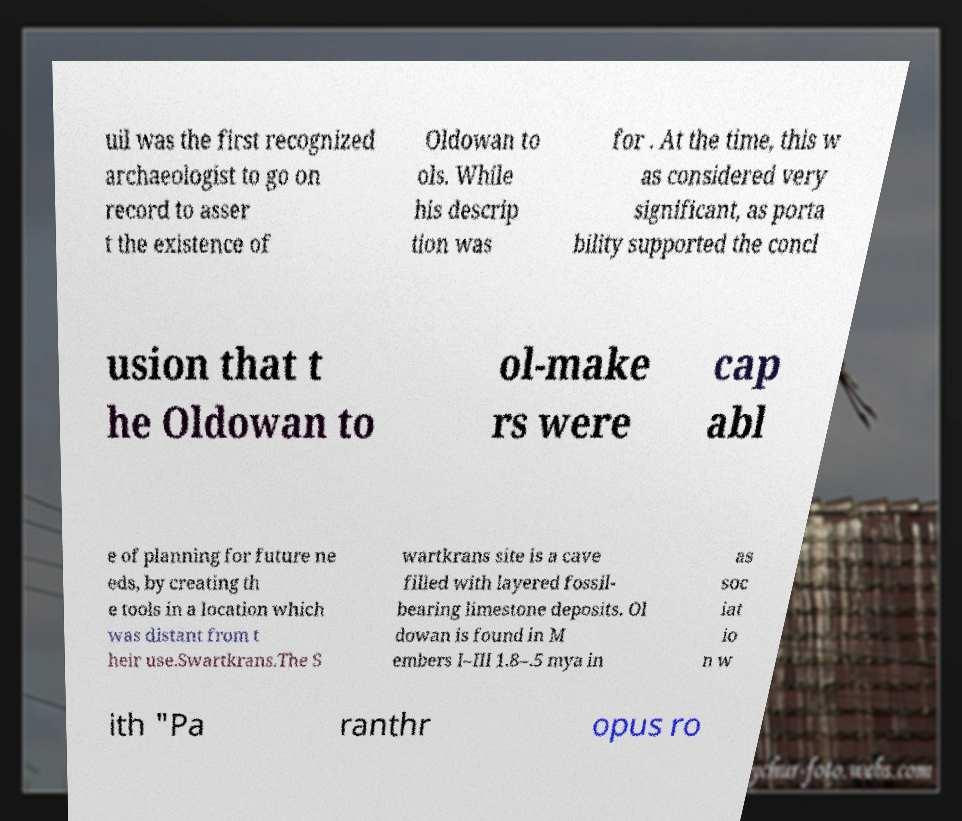For documentation purposes, I need the text within this image transcribed. Could you provide that? uil was the first recognized archaeologist to go on record to asser t the existence of Oldowan to ols. While his descrip tion was for . At the time, this w as considered very significant, as porta bility supported the concl usion that t he Oldowan to ol-make rs were cap abl e of planning for future ne eds, by creating th e tools in a location which was distant from t heir use.Swartkrans.The S wartkrans site is a cave filled with layered fossil- bearing limestone deposits. Ol dowan is found in M embers I–III 1.8–.5 mya in as soc iat io n w ith "Pa ranthr opus ro 